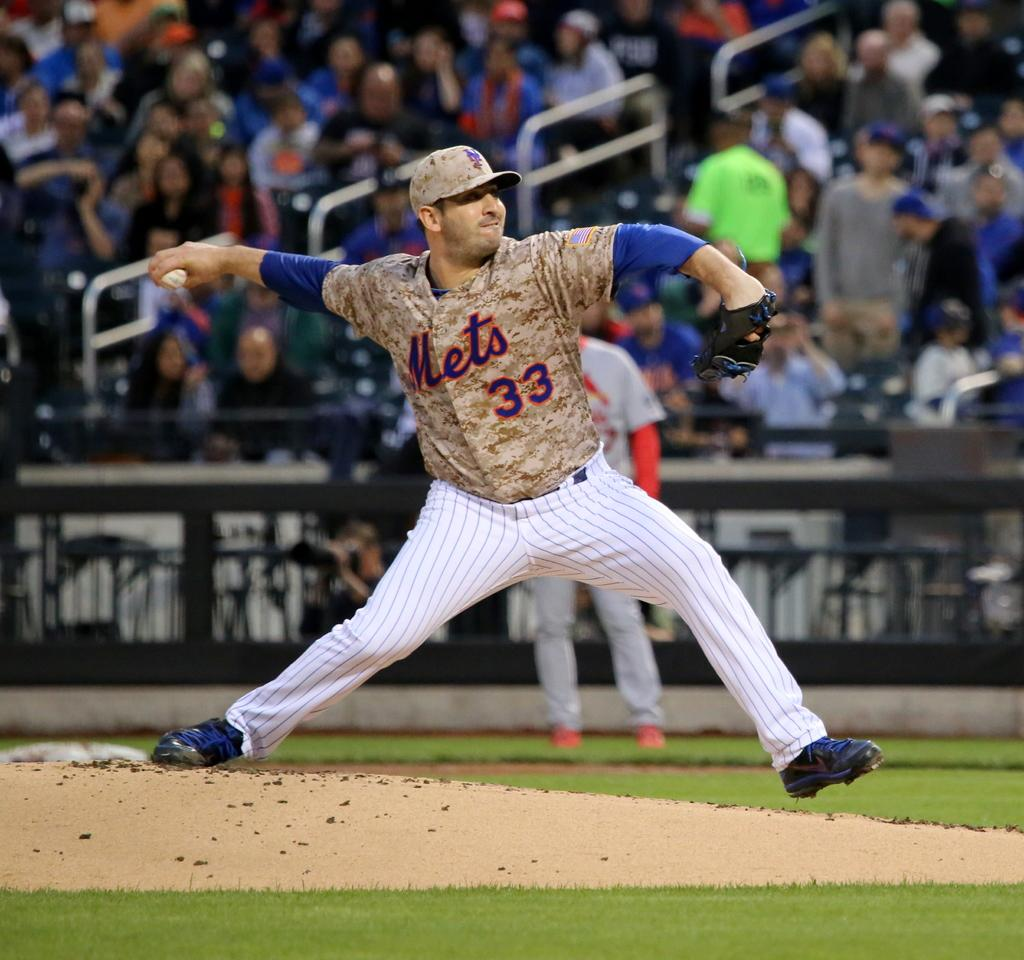<image>
Summarize the visual content of the image. Baseball player wearing number 33 pitching the ball. 